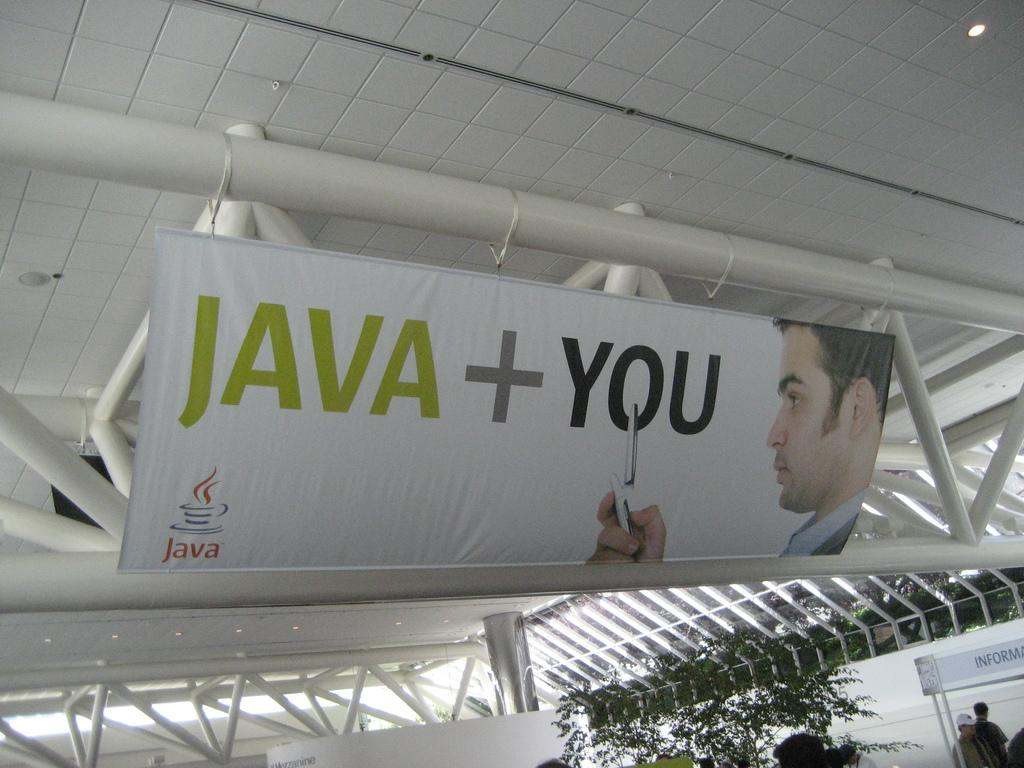<image>
Write a terse but informative summary of the picture. sign poster that reads java+ you with a cellphone 